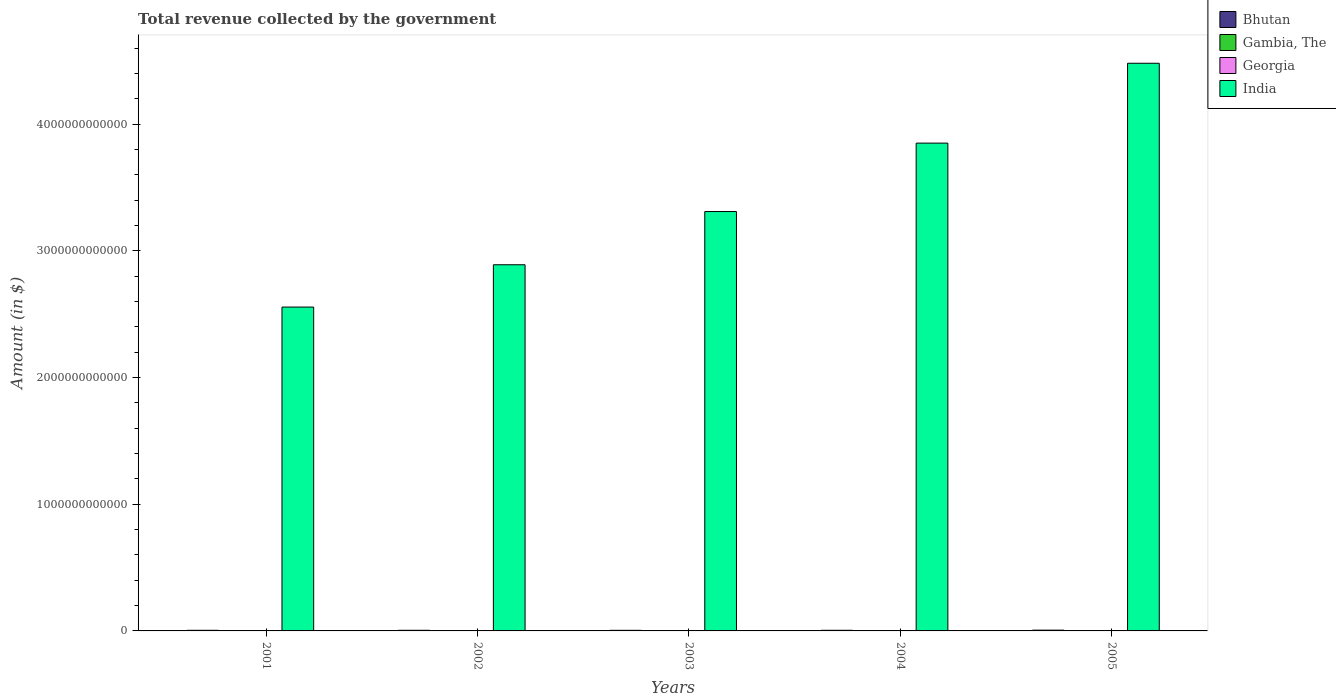How many different coloured bars are there?
Your answer should be compact. 4. Are the number of bars per tick equal to the number of legend labels?
Your answer should be very brief. Yes. Are the number of bars on each tick of the X-axis equal?
Ensure brevity in your answer.  Yes. What is the total revenue collected by the government in Gambia, The in 2001?
Your answer should be compact. 5.89e+08. Across all years, what is the maximum total revenue collected by the government in Georgia?
Offer a terse response. 2.11e+09. Across all years, what is the minimum total revenue collected by the government in India?
Keep it short and to the point. 2.56e+12. In which year was the total revenue collected by the government in India maximum?
Give a very brief answer. 2005. What is the total total revenue collected by the government in Bhutan in the graph?
Offer a terse response. 2.58e+1. What is the difference between the total revenue collected by the government in Bhutan in 2003 and that in 2004?
Your answer should be compact. -2.58e+08. What is the difference between the total revenue collected by the government in Georgia in 2003 and the total revenue collected by the government in India in 2002?
Your answer should be very brief. -2.89e+12. What is the average total revenue collected by the government in Gambia, The per year?
Your response must be concise. 1.13e+09. In the year 2003, what is the difference between the total revenue collected by the government in Gambia, The and total revenue collected by the government in India?
Give a very brief answer. -3.31e+12. In how many years, is the total revenue collected by the government in Gambia, The greater than 4200000000000 $?
Your answer should be compact. 0. What is the ratio of the total revenue collected by the government in India in 2001 to that in 2005?
Make the answer very short. 0.57. What is the difference between the highest and the second highest total revenue collected by the government in Gambia, The?
Give a very brief answer. 1.52e+08. What is the difference between the highest and the lowest total revenue collected by the government in Bhutan?
Give a very brief answer. 1.32e+09. In how many years, is the total revenue collected by the government in Bhutan greater than the average total revenue collected by the government in Bhutan taken over all years?
Provide a short and direct response. 1. Is the sum of the total revenue collected by the government in India in 2001 and 2002 greater than the maximum total revenue collected by the government in Gambia, The across all years?
Give a very brief answer. Yes. What does the 2nd bar from the left in 2001 represents?
Your answer should be very brief. Gambia, The. What does the 4th bar from the right in 2001 represents?
Make the answer very short. Bhutan. Is it the case that in every year, the sum of the total revenue collected by the government in India and total revenue collected by the government in Bhutan is greater than the total revenue collected by the government in Georgia?
Ensure brevity in your answer.  Yes. Are all the bars in the graph horizontal?
Provide a short and direct response. No. How many years are there in the graph?
Provide a succinct answer. 5. What is the difference between two consecutive major ticks on the Y-axis?
Offer a terse response. 1.00e+12. Are the values on the major ticks of Y-axis written in scientific E-notation?
Offer a very short reply. No. Does the graph contain any zero values?
Your answer should be compact. No. Where does the legend appear in the graph?
Your answer should be very brief. Top right. What is the title of the graph?
Provide a short and direct response. Total revenue collected by the government. Does "Thailand" appear as one of the legend labels in the graph?
Provide a succinct answer. No. What is the label or title of the X-axis?
Provide a short and direct response. Years. What is the label or title of the Y-axis?
Make the answer very short. Amount (in $). What is the Amount (in $) in Bhutan in 2001?
Ensure brevity in your answer.  4.90e+09. What is the Amount (in $) in Gambia, The in 2001?
Offer a terse response. 5.89e+08. What is the Amount (in $) of Georgia in 2001?
Your response must be concise. 6.92e+08. What is the Amount (in $) in India in 2001?
Your answer should be very brief. 2.56e+12. What is the Amount (in $) of Bhutan in 2002?
Your answer should be very brief. 5.04e+09. What is the Amount (in $) in Gambia, The in 2002?
Make the answer very short. 7.22e+08. What is the Amount (in $) of Georgia in 2002?
Offer a terse response. 7.80e+08. What is the Amount (in $) in India in 2002?
Ensure brevity in your answer.  2.89e+12. What is the Amount (in $) in Bhutan in 2003?
Make the answer very short. 4.75e+09. What is the Amount (in $) of Gambia, The in 2003?
Give a very brief answer. 9.69e+08. What is the Amount (in $) in Georgia in 2003?
Provide a short and direct response. 8.85e+08. What is the Amount (in $) of India in 2003?
Offer a very short reply. 3.31e+12. What is the Amount (in $) of Bhutan in 2004?
Your response must be concise. 5.00e+09. What is the Amount (in $) of Gambia, The in 2004?
Provide a short and direct response. 1.62e+09. What is the Amount (in $) in Georgia in 2004?
Offer a terse response. 1.57e+09. What is the Amount (in $) of India in 2004?
Ensure brevity in your answer.  3.85e+12. What is the Amount (in $) of Bhutan in 2005?
Your answer should be very brief. 6.07e+09. What is the Amount (in $) of Gambia, The in 2005?
Give a very brief answer. 1.77e+09. What is the Amount (in $) of Georgia in 2005?
Offer a terse response. 2.11e+09. What is the Amount (in $) in India in 2005?
Provide a succinct answer. 4.48e+12. Across all years, what is the maximum Amount (in $) in Bhutan?
Your response must be concise. 6.07e+09. Across all years, what is the maximum Amount (in $) of Gambia, The?
Offer a very short reply. 1.77e+09. Across all years, what is the maximum Amount (in $) of Georgia?
Give a very brief answer. 2.11e+09. Across all years, what is the maximum Amount (in $) of India?
Keep it short and to the point. 4.48e+12. Across all years, what is the minimum Amount (in $) in Bhutan?
Your answer should be very brief. 4.75e+09. Across all years, what is the minimum Amount (in $) of Gambia, The?
Provide a short and direct response. 5.89e+08. Across all years, what is the minimum Amount (in $) in Georgia?
Offer a very short reply. 6.92e+08. Across all years, what is the minimum Amount (in $) in India?
Give a very brief answer. 2.56e+12. What is the total Amount (in $) of Bhutan in the graph?
Keep it short and to the point. 2.58e+1. What is the total Amount (in $) in Gambia, The in the graph?
Make the answer very short. 5.67e+09. What is the total Amount (in $) in Georgia in the graph?
Provide a succinct answer. 6.04e+09. What is the total Amount (in $) of India in the graph?
Provide a short and direct response. 1.71e+13. What is the difference between the Amount (in $) of Bhutan in 2001 and that in 2002?
Keep it short and to the point. -1.44e+08. What is the difference between the Amount (in $) of Gambia, The in 2001 and that in 2002?
Keep it short and to the point. -1.33e+08. What is the difference between the Amount (in $) in Georgia in 2001 and that in 2002?
Your response must be concise. -8.79e+07. What is the difference between the Amount (in $) in India in 2001 and that in 2002?
Offer a very short reply. -3.34e+11. What is the difference between the Amount (in $) in Bhutan in 2001 and that in 2003?
Provide a short and direct response. 1.53e+08. What is the difference between the Amount (in $) of Gambia, The in 2001 and that in 2003?
Provide a succinct answer. -3.80e+08. What is the difference between the Amount (in $) of Georgia in 2001 and that in 2003?
Offer a terse response. -1.93e+08. What is the difference between the Amount (in $) of India in 2001 and that in 2003?
Your answer should be compact. -7.54e+11. What is the difference between the Amount (in $) in Bhutan in 2001 and that in 2004?
Provide a succinct answer. -1.04e+08. What is the difference between the Amount (in $) of Gambia, The in 2001 and that in 2004?
Your answer should be compact. -1.03e+09. What is the difference between the Amount (in $) of Georgia in 2001 and that in 2004?
Your answer should be compact. -8.81e+08. What is the difference between the Amount (in $) of India in 2001 and that in 2004?
Offer a very short reply. -1.29e+12. What is the difference between the Amount (in $) in Bhutan in 2001 and that in 2005?
Provide a short and direct response. -1.17e+09. What is the difference between the Amount (in $) in Gambia, The in 2001 and that in 2005?
Your answer should be very brief. -1.18e+09. What is the difference between the Amount (in $) in Georgia in 2001 and that in 2005?
Your answer should be compact. -1.42e+09. What is the difference between the Amount (in $) of India in 2001 and that in 2005?
Your answer should be compact. -1.92e+12. What is the difference between the Amount (in $) in Bhutan in 2002 and that in 2003?
Your answer should be compact. 2.97e+08. What is the difference between the Amount (in $) in Gambia, The in 2002 and that in 2003?
Your response must be concise. -2.47e+08. What is the difference between the Amount (in $) in Georgia in 2002 and that in 2003?
Provide a succinct answer. -1.05e+08. What is the difference between the Amount (in $) in India in 2002 and that in 2003?
Give a very brief answer. -4.20e+11. What is the difference between the Amount (in $) of Bhutan in 2002 and that in 2004?
Your answer should be very brief. 3.94e+07. What is the difference between the Amount (in $) in Gambia, The in 2002 and that in 2004?
Your answer should be compact. -8.96e+08. What is the difference between the Amount (in $) in Georgia in 2002 and that in 2004?
Ensure brevity in your answer.  -7.93e+08. What is the difference between the Amount (in $) in India in 2002 and that in 2004?
Your answer should be compact. -9.60e+11. What is the difference between the Amount (in $) in Bhutan in 2002 and that in 2005?
Give a very brief answer. -1.02e+09. What is the difference between the Amount (in $) of Gambia, The in 2002 and that in 2005?
Ensure brevity in your answer.  -1.05e+09. What is the difference between the Amount (in $) in Georgia in 2002 and that in 2005?
Your response must be concise. -1.33e+09. What is the difference between the Amount (in $) in India in 2002 and that in 2005?
Make the answer very short. -1.59e+12. What is the difference between the Amount (in $) of Bhutan in 2003 and that in 2004?
Your answer should be compact. -2.58e+08. What is the difference between the Amount (in $) in Gambia, The in 2003 and that in 2004?
Keep it short and to the point. -6.48e+08. What is the difference between the Amount (in $) of Georgia in 2003 and that in 2004?
Make the answer very short. -6.88e+08. What is the difference between the Amount (in $) of India in 2003 and that in 2004?
Offer a very short reply. -5.40e+11. What is the difference between the Amount (in $) in Bhutan in 2003 and that in 2005?
Your response must be concise. -1.32e+09. What is the difference between the Amount (in $) of Gambia, The in 2003 and that in 2005?
Provide a short and direct response. -8.01e+08. What is the difference between the Amount (in $) in Georgia in 2003 and that in 2005?
Your answer should be compact. -1.22e+09. What is the difference between the Amount (in $) of India in 2003 and that in 2005?
Provide a succinct answer. -1.17e+12. What is the difference between the Amount (in $) of Bhutan in 2004 and that in 2005?
Your answer should be compact. -1.06e+09. What is the difference between the Amount (in $) of Gambia, The in 2004 and that in 2005?
Provide a short and direct response. -1.52e+08. What is the difference between the Amount (in $) in Georgia in 2004 and that in 2005?
Your answer should be compact. -5.36e+08. What is the difference between the Amount (in $) of India in 2004 and that in 2005?
Your response must be concise. -6.30e+11. What is the difference between the Amount (in $) of Bhutan in 2001 and the Amount (in $) of Gambia, The in 2002?
Your answer should be compact. 4.18e+09. What is the difference between the Amount (in $) of Bhutan in 2001 and the Amount (in $) of Georgia in 2002?
Make the answer very short. 4.12e+09. What is the difference between the Amount (in $) in Bhutan in 2001 and the Amount (in $) in India in 2002?
Offer a terse response. -2.89e+12. What is the difference between the Amount (in $) in Gambia, The in 2001 and the Amount (in $) in Georgia in 2002?
Provide a succinct answer. -1.91e+08. What is the difference between the Amount (in $) in Gambia, The in 2001 and the Amount (in $) in India in 2002?
Offer a very short reply. -2.89e+12. What is the difference between the Amount (in $) in Georgia in 2001 and the Amount (in $) in India in 2002?
Your answer should be very brief. -2.89e+12. What is the difference between the Amount (in $) of Bhutan in 2001 and the Amount (in $) of Gambia, The in 2003?
Ensure brevity in your answer.  3.93e+09. What is the difference between the Amount (in $) in Bhutan in 2001 and the Amount (in $) in Georgia in 2003?
Ensure brevity in your answer.  4.01e+09. What is the difference between the Amount (in $) in Bhutan in 2001 and the Amount (in $) in India in 2003?
Your answer should be compact. -3.31e+12. What is the difference between the Amount (in $) in Gambia, The in 2001 and the Amount (in $) in Georgia in 2003?
Offer a terse response. -2.96e+08. What is the difference between the Amount (in $) in Gambia, The in 2001 and the Amount (in $) in India in 2003?
Your answer should be compact. -3.31e+12. What is the difference between the Amount (in $) in Georgia in 2001 and the Amount (in $) in India in 2003?
Make the answer very short. -3.31e+12. What is the difference between the Amount (in $) of Bhutan in 2001 and the Amount (in $) of Gambia, The in 2004?
Give a very brief answer. 3.28e+09. What is the difference between the Amount (in $) of Bhutan in 2001 and the Amount (in $) of Georgia in 2004?
Provide a succinct answer. 3.33e+09. What is the difference between the Amount (in $) of Bhutan in 2001 and the Amount (in $) of India in 2004?
Keep it short and to the point. -3.85e+12. What is the difference between the Amount (in $) in Gambia, The in 2001 and the Amount (in $) in Georgia in 2004?
Your response must be concise. -9.84e+08. What is the difference between the Amount (in $) of Gambia, The in 2001 and the Amount (in $) of India in 2004?
Ensure brevity in your answer.  -3.85e+12. What is the difference between the Amount (in $) of Georgia in 2001 and the Amount (in $) of India in 2004?
Keep it short and to the point. -3.85e+12. What is the difference between the Amount (in $) in Bhutan in 2001 and the Amount (in $) in Gambia, The in 2005?
Provide a succinct answer. 3.13e+09. What is the difference between the Amount (in $) in Bhutan in 2001 and the Amount (in $) in Georgia in 2005?
Ensure brevity in your answer.  2.79e+09. What is the difference between the Amount (in $) in Bhutan in 2001 and the Amount (in $) in India in 2005?
Make the answer very short. -4.48e+12. What is the difference between the Amount (in $) of Gambia, The in 2001 and the Amount (in $) of Georgia in 2005?
Provide a succinct answer. -1.52e+09. What is the difference between the Amount (in $) of Gambia, The in 2001 and the Amount (in $) of India in 2005?
Ensure brevity in your answer.  -4.48e+12. What is the difference between the Amount (in $) in Georgia in 2001 and the Amount (in $) in India in 2005?
Offer a terse response. -4.48e+12. What is the difference between the Amount (in $) in Bhutan in 2002 and the Amount (in $) in Gambia, The in 2003?
Keep it short and to the point. 4.07e+09. What is the difference between the Amount (in $) in Bhutan in 2002 and the Amount (in $) in Georgia in 2003?
Keep it short and to the point. 4.16e+09. What is the difference between the Amount (in $) in Bhutan in 2002 and the Amount (in $) in India in 2003?
Offer a very short reply. -3.30e+12. What is the difference between the Amount (in $) in Gambia, The in 2002 and the Amount (in $) in Georgia in 2003?
Give a very brief answer. -1.63e+08. What is the difference between the Amount (in $) in Gambia, The in 2002 and the Amount (in $) in India in 2003?
Your answer should be compact. -3.31e+12. What is the difference between the Amount (in $) in Georgia in 2002 and the Amount (in $) in India in 2003?
Make the answer very short. -3.31e+12. What is the difference between the Amount (in $) in Bhutan in 2002 and the Amount (in $) in Gambia, The in 2004?
Ensure brevity in your answer.  3.43e+09. What is the difference between the Amount (in $) in Bhutan in 2002 and the Amount (in $) in Georgia in 2004?
Provide a short and direct response. 3.47e+09. What is the difference between the Amount (in $) in Bhutan in 2002 and the Amount (in $) in India in 2004?
Your answer should be very brief. -3.84e+12. What is the difference between the Amount (in $) of Gambia, The in 2002 and the Amount (in $) of Georgia in 2004?
Ensure brevity in your answer.  -8.51e+08. What is the difference between the Amount (in $) of Gambia, The in 2002 and the Amount (in $) of India in 2004?
Ensure brevity in your answer.  -3.85e+12. What is the difference between the Amount (in $) in Georgia in 2002 and the Amount (in $) in India in 2004?
Provide a short and direct response. -3.85e+12. What is the difference between the Amount (in $) of Bhutan in 2002 and the Amount (in $) of Gambia, The in 2005?
Offer a terse response. 3.27e+09. What is the difference between the Amount (in $) of Bhutan in 2002 and the Amount (in $) of Georgia in 2005?
Provide a short and direct response. 2.94e+09. What is the difference between the Amount (in $) in Bhutan in 2002 and the Amount (in $) in India in 2005?
Your response must be concise. -4.48e+12. What is the difference between the Amount (in $) in Gambia, The in 2002 and the Amount (in $) in Georgia in 2005?
Provide a short and direct response. -1.39e+09. What is the difference between the Amount (in $) in Gambia, The in 2002 and the Amount (in $) in India in 2005?
Your answer should be very brief. -4.48e+12. What is the difference between the Amount (in $) of Georgia in 2002 and the Amount (in $) of India in 2005?
Your answer should be compact. -4.48e+12. What is the difference between the Amount (in $) of Bhutan in 2003 and the Amount (in $) of Gambia, The in 2004?
Offer a terse response. 3.13e+09. What is the difference between the Amount (in $) in Bhutan in 2003 and the Amount (in $) in Georgia in 2004?
Provide a short and direct response. 3.17e+09. What is the difference between the Amount (in $) in Bhutan in 2003 and the Amount (in $) in India in 2004?
Ensure brevity in your answer.  -3.85e+12. What is the difference between the Amount (in $) of Gambia, The in 2003 and the Amount (in $) of Georgia in 2004?
Offer a terse response. -6.04e+08. What is the difference between the Amount (in $) of Gambia, The in 2003 and the Amount (in $) of India in 2004?
Provide a short and direct response. -3.85e+12. What is the difference between the Amount (in $) of Georgia in 2003 and the Amount (in $) of India in 2004?
Ensure brevity in your answer.  -3.85e+12. What is the difference between the Amount (in $) of Bhutan in 2003 and the Amount (in $) of Gambia, The in 2005?
Keep it short and to the point. 2.98e+09. What is the difference between the Amount (in $) of Bhutan in 2003 and the Amount (in $) of Georgia in 2005?
Keep it short and to the point. 2.64e+09. What is the difference between the Amount (in $) in Bhutan in 2003 and the Amount (in $) in India in 2005?
Make the answer very short. -4.48e+12. What is the difference between the Amount (in $) in Gambia, The in 2003 and the Amount (in $) in Georgia in 2005?
Provide a short and direct response. -1.14e+09. What is the difference between the Amount (in $) in Gambia, The in 2003 and the Amount (in $) in India in 2005?
Your response must be concise. -4.48e+12. What is the difference between the Amount (in $) in Georgia in 2003 and the Amount (in $) in India in 2005?
Give a very brief answer. -4.48e+12. What is the difference between the Amount (in $) of Bhutan in 2004 and the Amount (in $) of Gambia, The in 2005?
Your answer should be compact. 3.23e+09. What is the difference between the Amount (in $) in Bhutan in 2004 and the Amount (in $) in Georgia in 2005?
Your response must be concise. 2.90e+09. What is the difference between the Amount (in $) in Bhutan in 2004 and the Amount (in $) in India in 2005?
Give a very brief answer. -4.48e+12. What is the difference between the Amount (in $) in Gambia, The in 2004 and the Amount (in $) in Georgia in 2005?
Keep it short and to the point. -4.91e+08. What is the difference between the Amount (in $) in Gambia, The in 2004 and the Amount (in $) in India in 2005?
Keep it short and to the point. -4.48e+12. What is the difference between the Amount (in $) of Georgia in 2004 and the Amount (in $) of India in 2005?
Make the answer very short. -4.48e+12. What is the average Amount (in $) in Bhutan per year?
Your answer should be compact. 5.15e+09. What is the average Amount (in $) in Gambia, The per year?
Ensure brevity in your answer.  1.13e+09. What is the average Amount (in $) in Georgia per year?
Your answer should be very brief. 1.21e+09. What is the average Amount (in $) in India per year?
Give a very brief answer. 3.42e+12. In the year 2001, what is the difference between the Amount (in $) in Bhutan and Amount (in $) in Gambia, The?
Your response must be concise. 4.31e+09. In the year 2001, what is the difference between the Amount (in $) of Bhutan and Amount (in $) of Georgia?
Offer a very short reply. 4.21e+09. In the year 2001, what is the difference between the Amount (in $) of Bhutan and Amount (in $) of India?
Your response must be concise. -2.55e+12. In the year 2001, what is the difference between the Amount (in $) of Gambia, The and Amount (in $) of Georgia?
Offer a terse response. -1.03e+08. In the year 2001, what is the difference between the Amount (in $) in Gambia, The and Amount (in $) in India?
Your answer should be very brief. -2.56e+12. In the year 2001, what is the difference between the Amount (in $) in Georgia and Amount (in $) in India?
Offer a terse response. -2.56e+12. In the year 2002, what is the difference between the Amount (in $) in Bhutan and Amount (in $) in Gambia, The?
Provide a succinct answer. 4.32e+09. In the year 2002, what is the difference between the Amount (in $) in Bhutan and Amount (in $) in Georgia?
Offer a very short reply. 4.26e+09. In the year 2002, what is the difference between the Amount (in $) of Bhutan and Amount (in $) of India?
Your answer should be compact. -2.88e+12. In the year 2002, what is the difference between the Amount (in $) in Gambia, The and Amount (in $) in Georgia?
Offer a terse response. -5.80e+07. In the year 2002, what is the difference between the Amount (in $) of Gambia, The and Amount (in $) of India?
Your answer should be compact. -2.89e+12. In the year 2002, what is the difference between the Amount (in $) of Georgia and Amount (in $) of India?
Ensure brevity in your answer.  -2.89e+12. In the year 2003, what is the difference between the Amount (in $) in Bhutan and Amount (in $) in Gambia, The?
Offer a very short reply. 3.78e+09. In the year 2003, what is the difference between the Amount (in $) in Bhutan and Amount (in $) in Georgia?
Your answer should be very brief. 3.86e+09. In the year 2003, what is the difference between the Amount (in $) in Bhutan and Amount (in $) in India?
Make the answer very short. -3.31e+12. In the year 2003, what is the difference between the Amount (in $) in Gambia, The and Amount (in $) in Georgia?
Make the answer very short. 8.43e+07. In the year 2003, what is the difference between the Amount (in $) of Gambia, The and Amount (in $) of India?
Your answer should be very brief. -3.31e+12. In the year 2003, what is the difference between the Amount (in $) in Georgia and Amount (in $) in India?
Ensure brevity in your answer.  -3.31e+12. In the year 2004, what is the difference between the Amount (in $) of Bhutan and Amount (in $) of Gambia, The?
Your answer should be compact. 3.39e+09. In the year 2004, what is the difference between the Amount (in $) in Bhutan and Amount (in $) in Georgia?
Make the answer very short. 3.43e+09. In the year 2004, what is the difference between the Amount (in $) in Bhutan and Amount (in $) in India?
Keep it short and to the point. -3.85e+12. In the year 2004, what is the difference between the Amount (in $) of Gambia, The and Amount (in $) of Georgia?
Provide a succinct answer. 4.49e+07. In the year 2004, what is the difference between the Amount (in $) in Gambia, The and Amount (in $) in India?
Provide a succinct answer. -3.85e+12. In the year 2004, what is the difference between the Amount (in $) in Georgia and Amount (in $) in India?
Offer a very short reply. -3.85e+12. In the year 2005, what is the difference between the Amount (in $) in Bhutan and Amount (in $) in Gambia, The?
Provide a succinct answer. 4.30e+09. In the year 2005, what is the difference between the Amount (in $) in Bhutan and Amount (in $) in Georgia?
Your answer should be very brief. 3.96e+09. In the year 2005, what is the difference between the Amount (in $) of Bhutan and Amount (in $) of India?
Provide a succinct answer. -4.47e+12. In the year 2005, what is the difference between the Amount (in $) of Gambia, The and Amount (in $) of Georgia?
Your answer should be compact. -3.39e+08. In the year 2005, what is the difference between the Amount (in $) in Gambia, The and Amount (in $) in India?
Offer a terse response. -4.48e+12. In the year 2005, what is the difference between the Amount (in $) in Georgia and Amount (in $) in India?
Ensure brevity in your answer.  -4.48e+12. What is the ratio of the Amount (in $) in Bhutan in 2001 to that in 2002?
Make the answer very short. 0.97. What is the ratio of the Amount (in $) in Gambia, The in 2001 to that in 2002?
Offer a terse response. 0.82. What is the ratio of the Amount (in $) in Georgia in 2001 to that in 2002?
Offer a very short reply. 0.89. What is the ratio of the Amount (in $) of India in 2001 to that in 2002?
Keep it short and to the point. 0.88. What is the ratio of the Amount (in $) in Bhutan in 2001 to that in 2003?
Keep it short and to the point. 1.03. What is the ratio of the Amount (in $) in Gambia, The in 2001 to that in 2003?
Your answer should be compact. 0.61. What is the ratio of the Amount (in $) in Georgia in 2001 to that in 2003?
Provide a succinct answer. 0.78. What is the ratio of the Amount (in $) in India in 2001 to that in 2003?
Make the answer very short. 0.77. What is the ratio of the Amount (in $) in Bhutan in 2001 to that in 2004?
Offer a terse response. 0.98. What is the ratio of the Amount (in $) in Gambia, The in 2001 to that in 2004?
Make the answer very short. 0.36. What is the ratio of the Amount (in $) in Georgia in 2001 to that in 2004?
Your answer should be compact. 0.44. What is the ratio of the Amount (in $) in India in 2001 to that in 2004?
Make the answer very short. 0.66. What is the ratio of the Amount (in $) of Bhutan in 2001 to that in 2005?
Provide a succinct answer. 0.81. What is the ratio of the Amount (in $) in Gambia, The in 2001 to that in 2005?
Keep it short and to the point. 0.33. What is the ratio of the Amount (in $) in Georgia in 2001 to that in 2005?
Your answer should be very brief. 0.33. What is the ratio of the Amount (in $) of India in 2001 to that in 2005?
Your response must be concise. 0.57. What is the ratio of the Amount (in $) in Bhutan in 2002 to that in 2003?
Keep it short and to the point. 1.06. What is the ratio of the Amount (in $) in Gambia, The in 2002 to that in 2003?
Provide a short and direct response. 0.74. What is the ratio of the Amount (in $) of Georgia in 2002 to that in 2003?
Provide a succinct answer. 0.88. What is the ratio of the Amount (in $) in India in 2002 to that in 2003?
Ensure brevity in your answer.  0.87. What is the ratio of the Amount (in $) in Bhutan in 2002 to that in 2004?
Make the answer very short. 1.01. What is the ratio of the Amount (in $) of Gambia, The in 2002 to that in 2004?
Give a very brief answer. 0.45. What is the ratio of the Amount (in $) in Georgia in 2002 to that in 2004?
Offer a very short reply. 0.5. What is the ratio of the Amount (in $) of India in 2002 to that in 2004?
Give a very brief answer. 0.75. What is the ratio of the Amount (in $) of Bhutan in 2002 to that in 2005?
Make the answer very short. 0.83. What is the ratio of the Amount (in $) of Gambia, The in 2002 to that in 2005?
Offer a very short reply. 0.41. What is the ratio of the Amount (in $) in Georgia in 2002 to that in 2005?
Your answer should be compact. 0.37. What is the ratio of the Amount (in $) of India in 2002 to that in 2005?
Offer a very short reply. 0.65. What is the ratio of the Amount (in $) in Bhutan in 2003 to that in 2004?
Your response must be concise. 0.95. What is the ratio of the Amount (in $) of Gambia, The in 2003 to that in 2004?
Your answer should be very brief. 0.6. What is the ratio of the Amount (in $) in Georgia in 2003 to that in 2004?
Provide a short and direct response. 0.56. What is the ratio of the Amount (in $) in India in 2003 to that in 2004?
Keep it short and to the point. 0.86. What is the ratio of the Amount (in $) in Bhutan in 2003 to that in 2005?
Your response must be concise. 0.78. What is the ratio of the Amount (in $) in Gambia, The in 2003 to that in 2005?
Offer a terse response. 0.55. What is the ratio of the Amount (in $) in Georgia in 2003 to that in 2005?
Offer a very short reply. 0.42. What is the ratio of the Amount (in $) in India in 2003 to that in 2005?
Provide a short and direct response. 0.74. What is the ratio of the Amount (in $) of Bhutan in 2004 to that in 2005?
Provide a succinct answer. 0.82. What is the ratio of the Amount (in $) of Gambia, The in 2004 to that in 2005?
Ensure brevity in your answer.  0.91. What is the ratio of the Amount (in $) in Georgia in 2004 to that in 2005?
Offer a very short reply. 0.75. What is the ratio of the Amount (in $) in India in 2004 to that in 2005?
Provide a succinct answer. 0.86. What is the difference between the highest and the second highest Amount (in $) in Bhutan?
Offer a very short reply. 1.02e+09. What is the difference between the highest and the second highest Amount (in $) of Gambia, The?
Keep it short and to the point. 1.52e+08. What is the difference between the highest and the second highest Amount (in $) in Georgia?
Provide a short and direct response. 5.36e+08. What is the difference between the highest and the second highest Amount (in $) of India?
Provide a short and direct response. 6.30e+11. What is the difference between the highest and the lowest Amount (in $) of Bhutan?
Your answer should be very brief. 1.32e+09. What is the difference between the highest and the lowest Amount (in $) in Gambia, The?
Ensure brevity in your answer.  1.18e+09. What is the difference between the highest and the lowest Amount (in $) of Georgia?
Your response must be concise. 1.42e+09. What is the difference between the highest and the lowest Amount (in $) in India?
Give a very brief answer. 1.92e+12. 